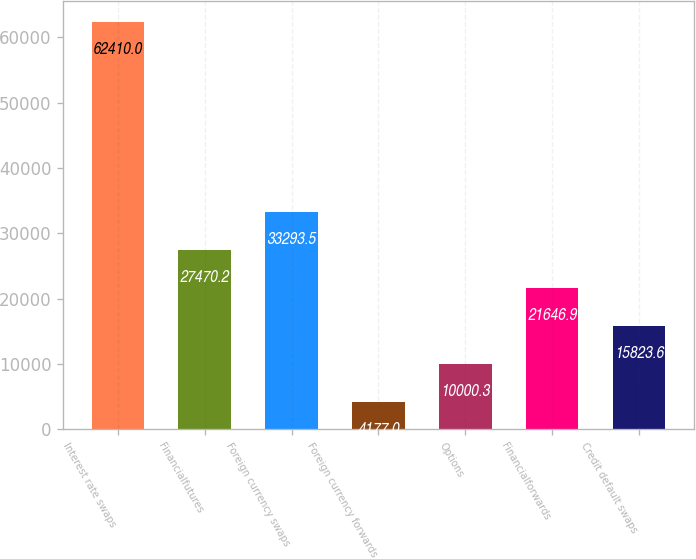Convert chart. <chart><loc_0><loc_0><loc_500><loc_500><bar_chart><fcel>Interest rate swaps<fcel>Financialfutures<fcel>Foreign currency swaps<fcel>Foreign currency forwards<fcel>Options<fcel>Financialforwards<fcel>Credit default swaps<nl><fcel>62410<fcel>27470.2<fcel>33293.5<fcel>4177<fcel>10000.3<fcel>21646.9<fcel>15823.6<nl></chart> 